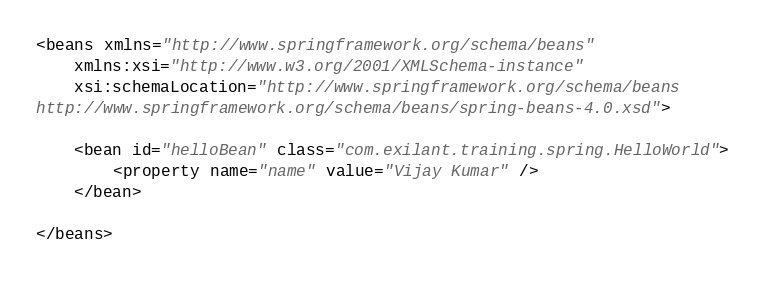Convert code to text. <code><loc_0><loc_0><loc_500><loc_500><_XML_><beans xmlns="http://www.springframework.org/schema/beans" 
	xmlns:xsi="http://www.w3.org/2001/XMLSchema-instance"
	xsi:schemaLocation="http://www.springframework.org/schema/beans
http://www.springframework.org/schema/beans/spring-beans-4.0.xsd">

	<bean id="helloBean" class="com.exilant.training.spring.HelloWorld">
		<property name="name" value="Vijay Kumar" />
	</bean>

</beans></code> 